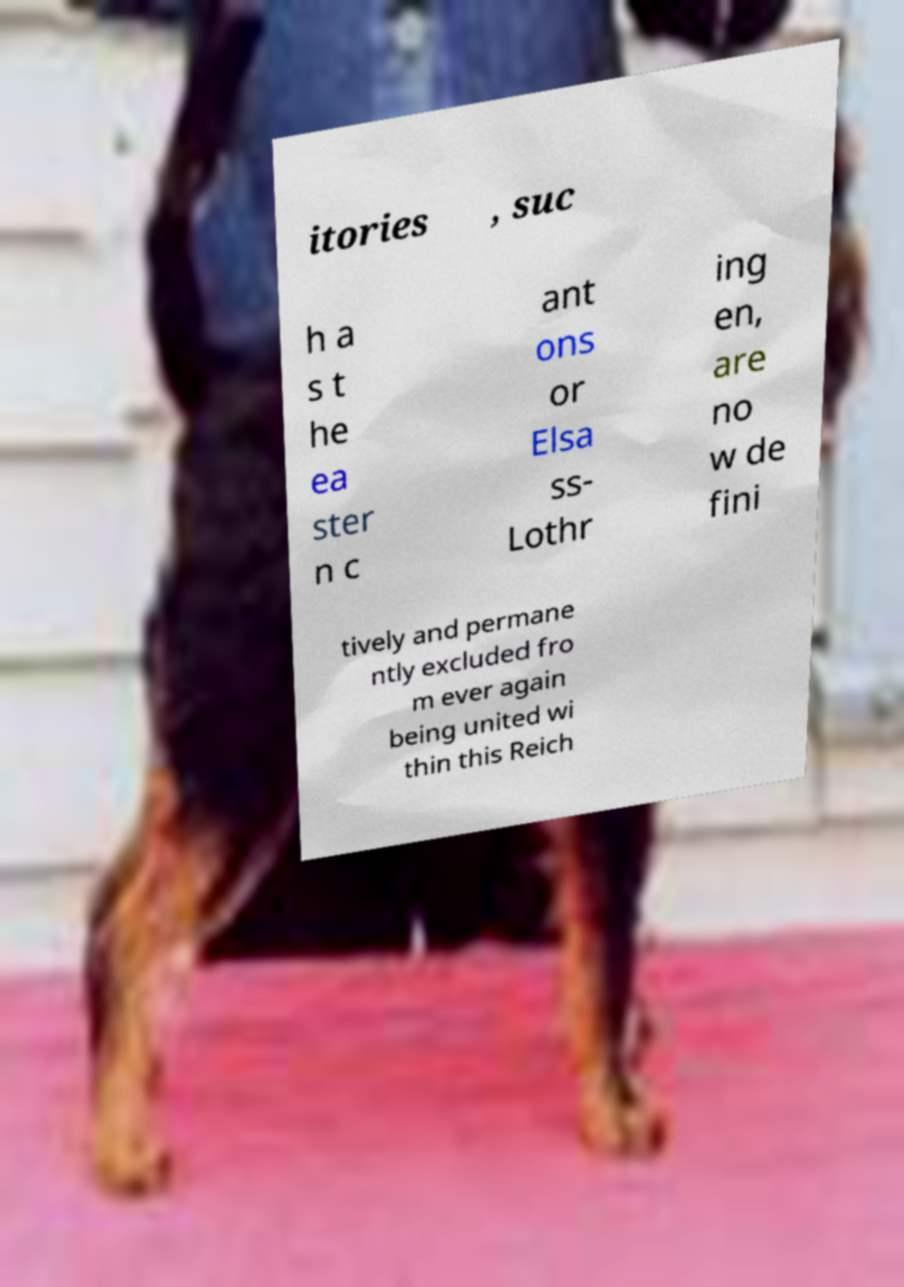Please identify and transcribe the text found in this image. itories , suc h a s t he ea ster n c ant ons or Elsa ss- Lothr ing en, are no w de fini tively and permane ntly excluded fro m ever again being united wi thin this Reich 